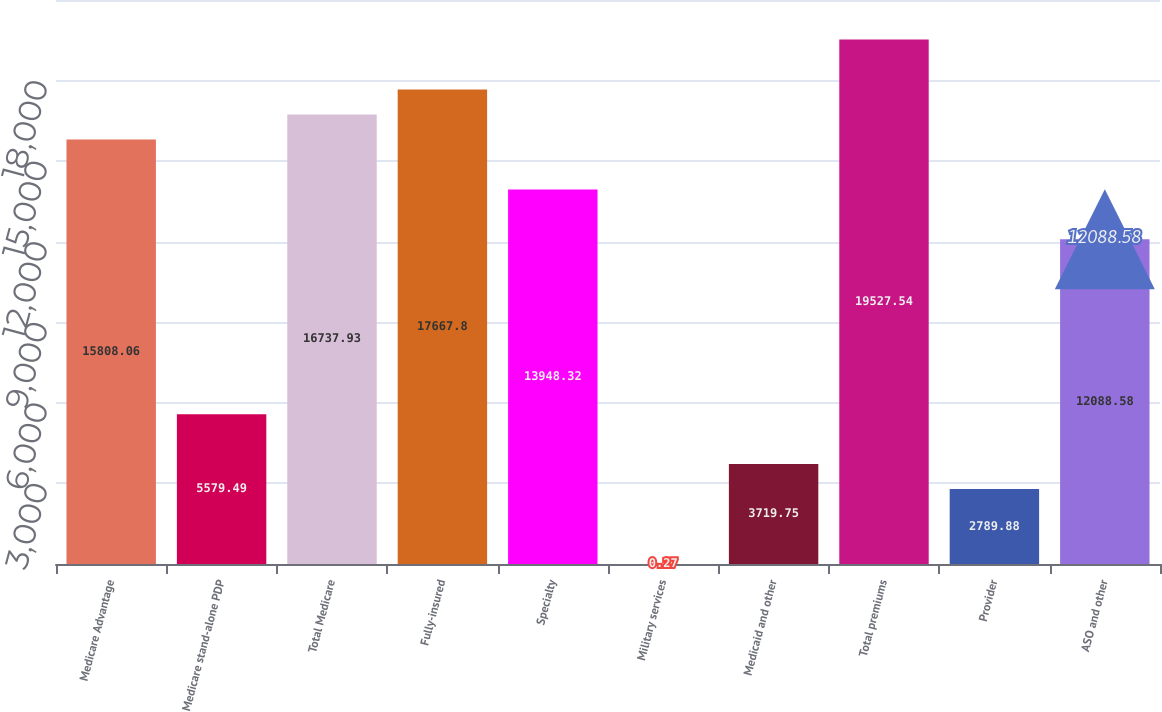Convert chart. <chart><loc_0><loc_0><loc_500><loc_500><bar_chart><fcel>Medicare Advantage<fcel>Medicare stand-alone PDP<fcel>Total Medicare<fcel>Fully-insured<fcel>Specialty<fcel>Military services<fcel>Medicaid and other<fcel>Total premiums<fcel>Provider<fcel>ASO and other<nl><fcel>15808.1<fcel>5579.49<fcel>16737.9<fcel>17667.8<fcel>13948.3<fcel>0.27<fcel>3719.75<fcel>19527.5<fcel>2789.88<fcel>12088.6<nl></chart> 